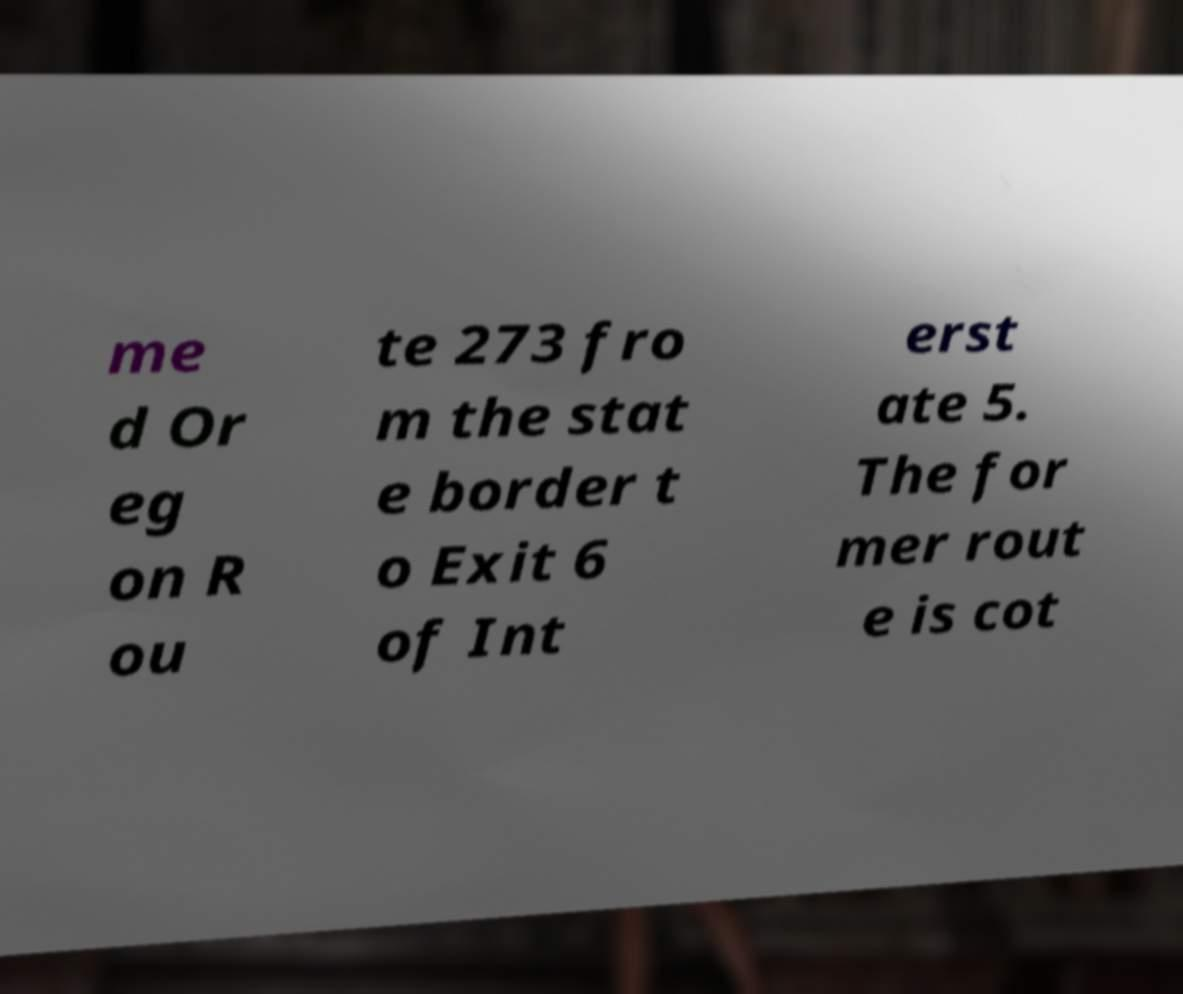Can you read and provide the text displayed in the image?This photo seems to have some interesting text. Can you extract and type it out for me? me d Or eg on R ou te 273 fro m the stat e border t o Exit 6 of Int erst ate 5. The for mer rout e is cot 